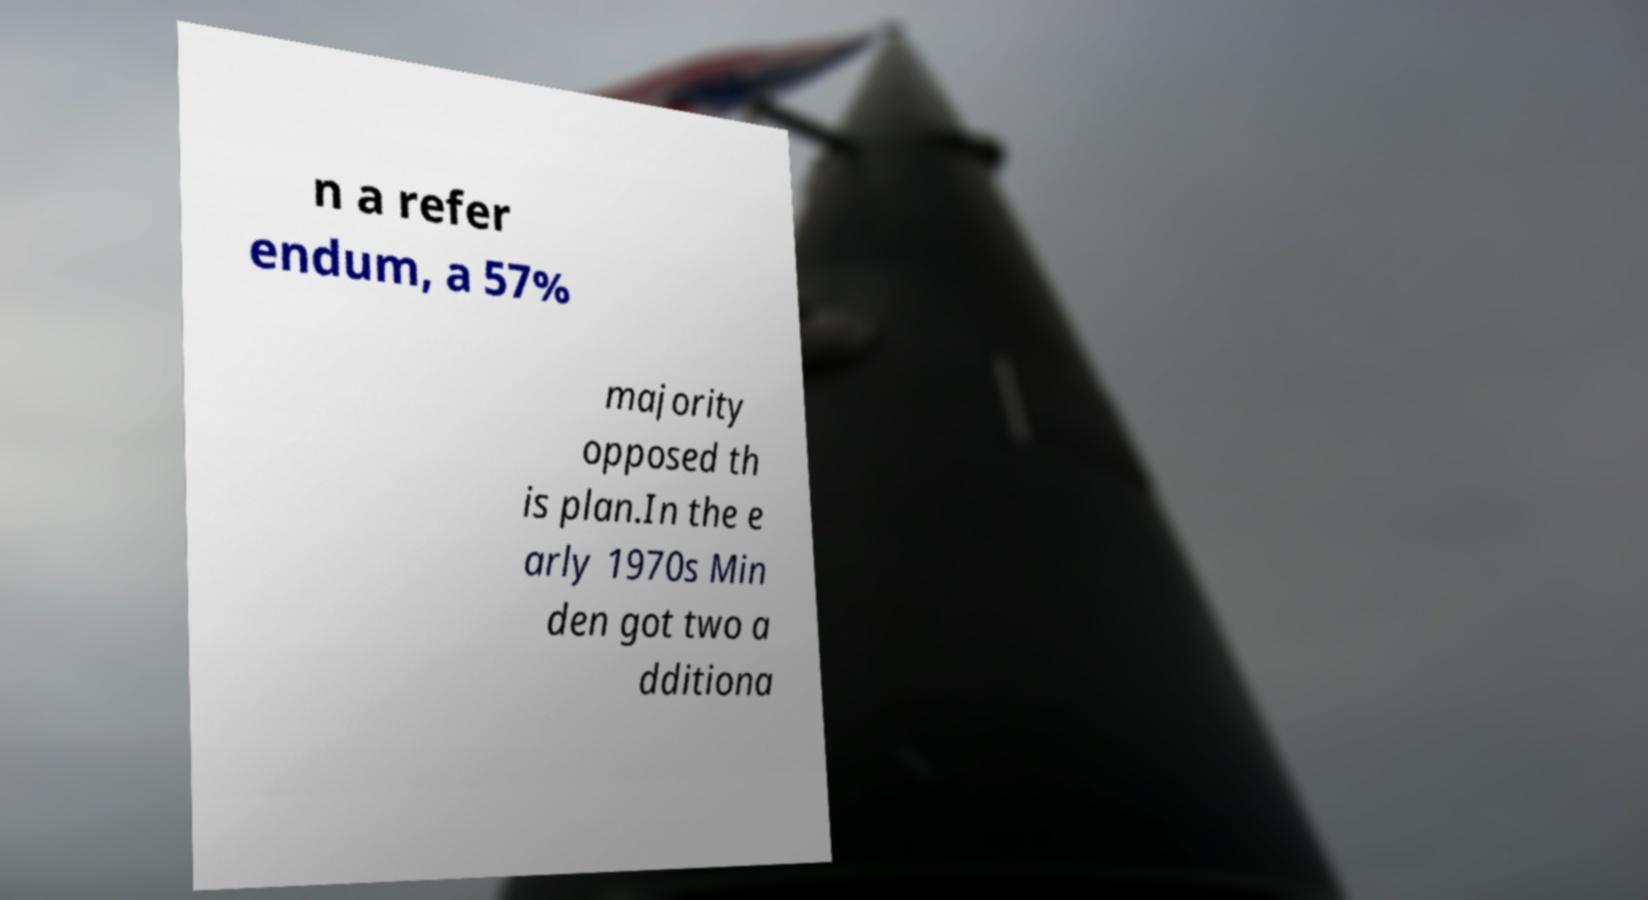What messages or text are displayed in this image? I need them in a readable, typed format. n a refer endum, a 57% majority opposed th is plan.In the e arly 1970s Min den got two a dditiona 